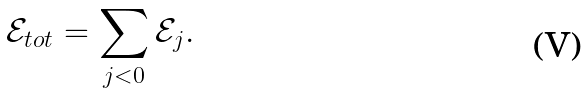<formula> <loc_0><loc_0><loc_500><loc_500>\mathcal { E } _ { t o t } = \sum _ { j < 0 } \mathcal { E } _ { j } .</formula> 